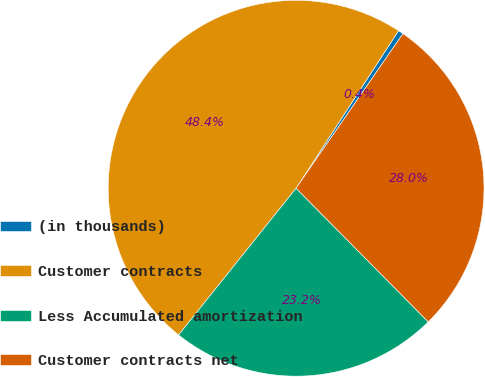<chart> <loc_0><loc_0><loc_500><loc_500><pie_chart><fcel>(in thousands)<fcel>Customer contracts<fcel>Less Accumulated amortization<fcel>Customer contracts net<nl><fcel>0.45%<fcel>48.43%<fcel>23.16%<fcel>27.96%<nl></chart> 